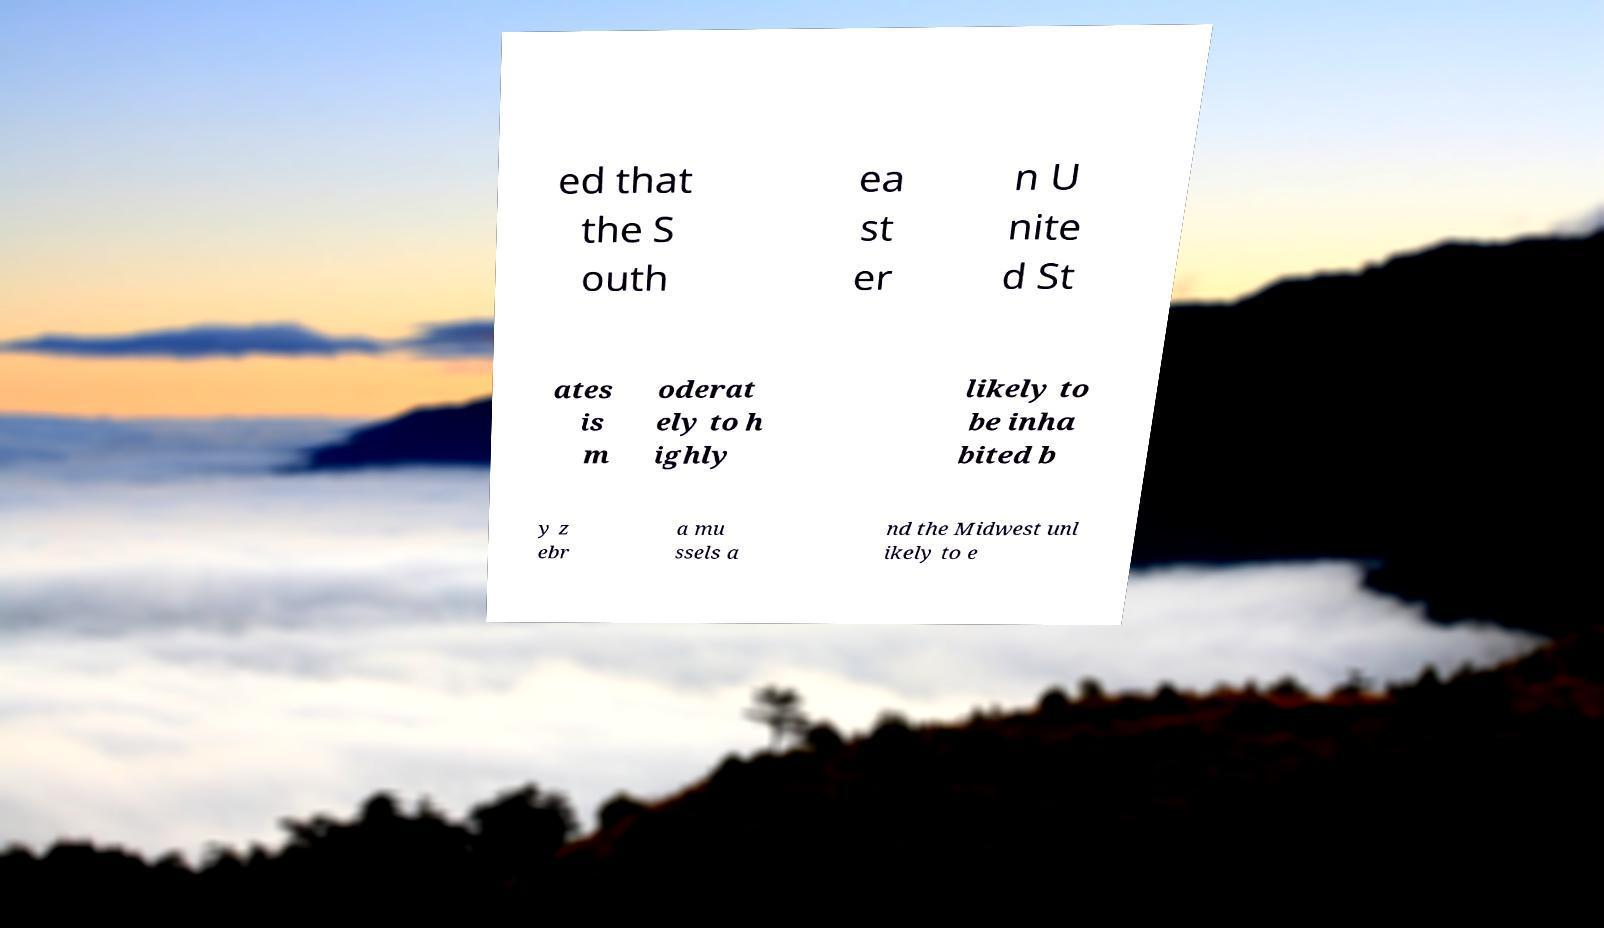There's text embedded in this image that I need extracted. Can you transcribe it verbatim? ed that the S outh ea st er n U nite d St ates is m oderat ely to h ighly likely to be inha bited b y z ebr a mu ssels a nd the Midwest unl ikely to e 